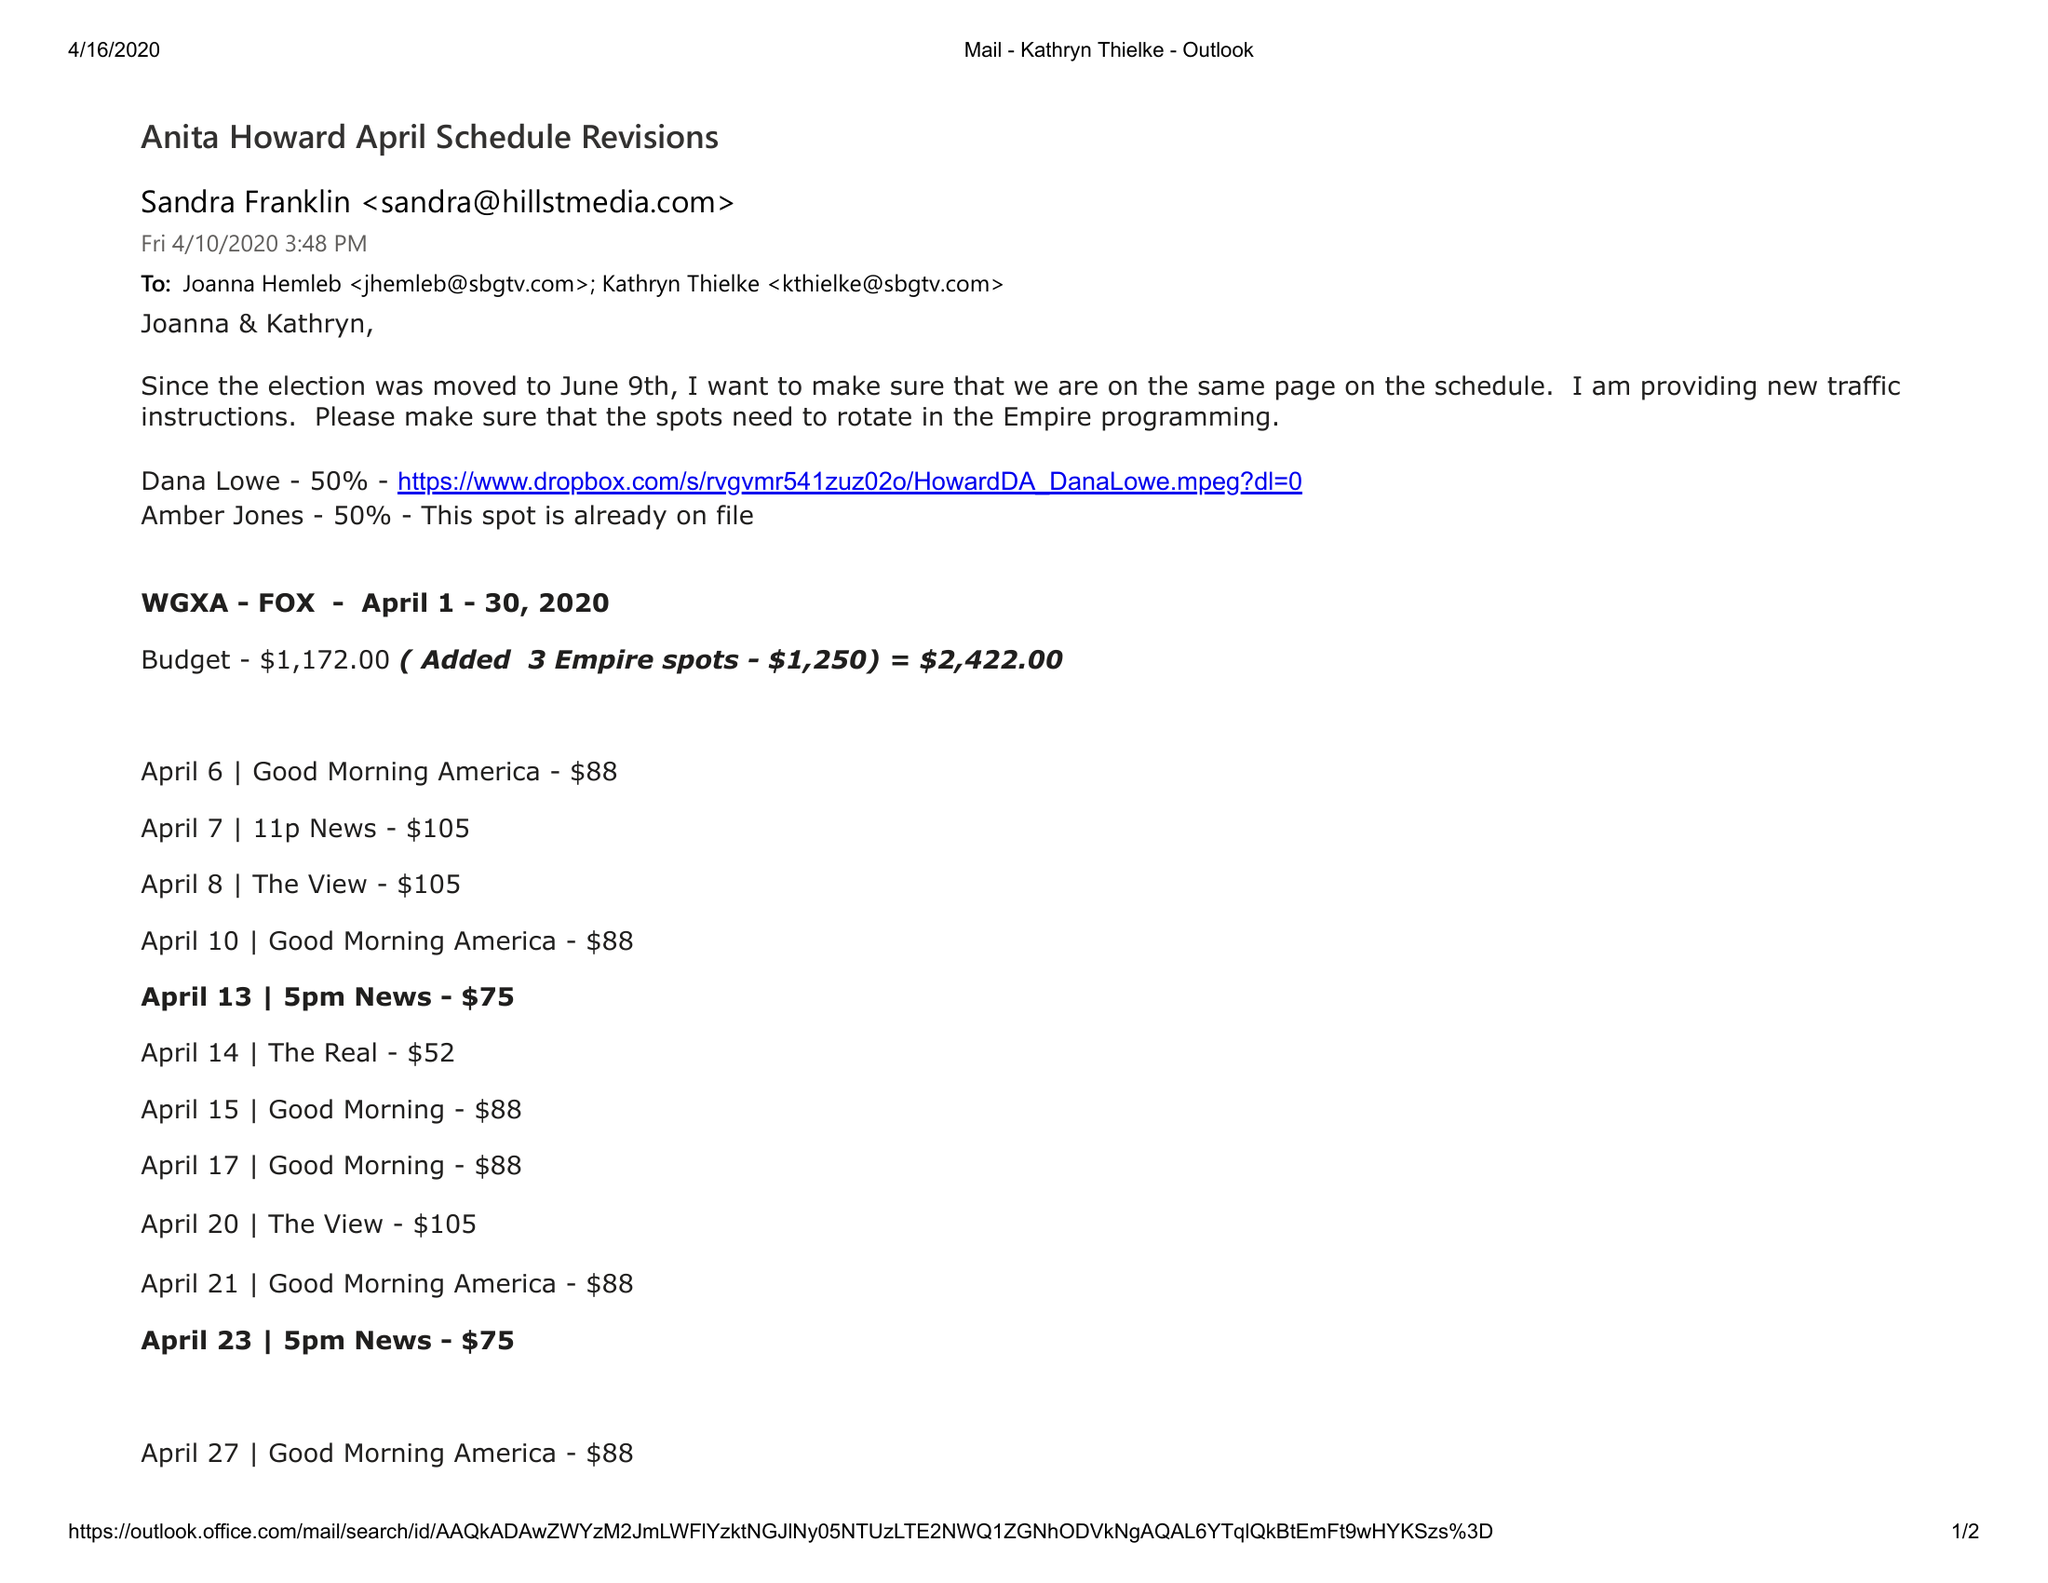What is the value for the flight_from?
Answer the question using a single word or phrase. 04/01/20 